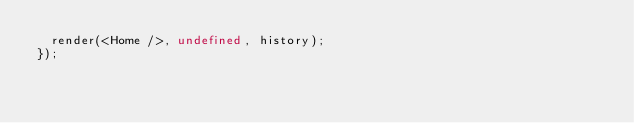Convert code to text. <code><loc_0><loc_0><loc_500><loc_500><_TypeScript_>  render(<Home />, undefined, history);
});
</code> 